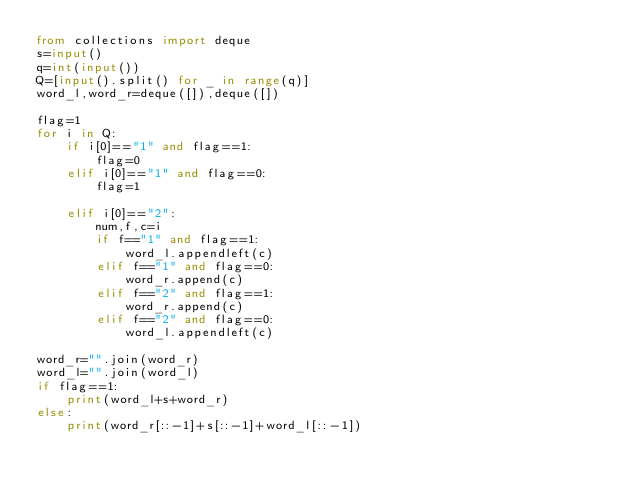<code> <loc_0><loc_0><loc_500><loc_500><_Python_>from collections import deque
s=input()
q=int(input())
Q=[input().split() for _ in range(q)]
word_l,word_r=deque([]),deque([])

flag=1
for i in Q:
    if i[0]=="1" and flag==1:
        flag=0
    elif i[0]=="1" and flag==0:
        flag=1

    elif i[0]=="2":
        num,f,c=i
        if f=="1" and flag==1:
            word_l.appendleft(c)
        elif f=="1" and flag==0:
            word_r.append(c)
        elif f=="2" and flag==1:
            word_r.append(c)
        elif f=="2" and flag==0:
            word_l.appendleft(c)

word_r="".join(word_r)
word_l="".join(word_l)
if flag==1:
    print(word_l+s+word_r)
else:
    print(word_r[::-1]+s[::-1]+word_l[::-1])</code> 